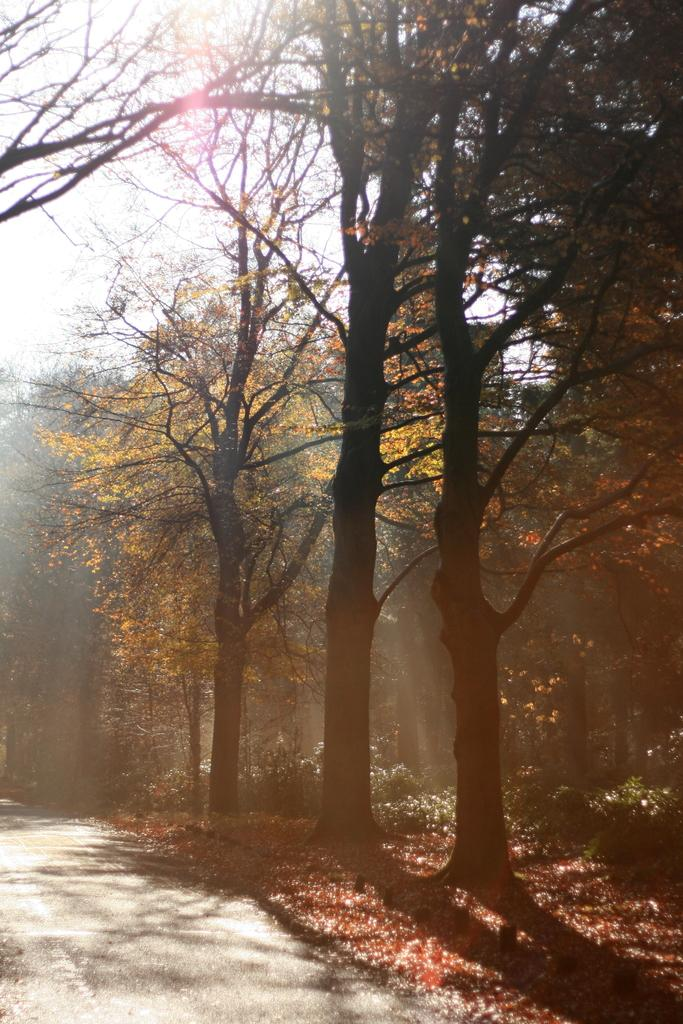What is the main feature of the image? There is a road in the image. What can be seen on the ground near the road? There are dried leaves on the land. What type of vegetation is present in the image? There are trees in the image. What is visible in the background of the image? The sky is visible in the background of the image. How many ladybugs can be seen crawling on the trees in the image? There are no ladybugs visible in the image; only trees are present. Are there any horses running along the road in the image? There are no horses visible in the image; only a road and trees are present. 